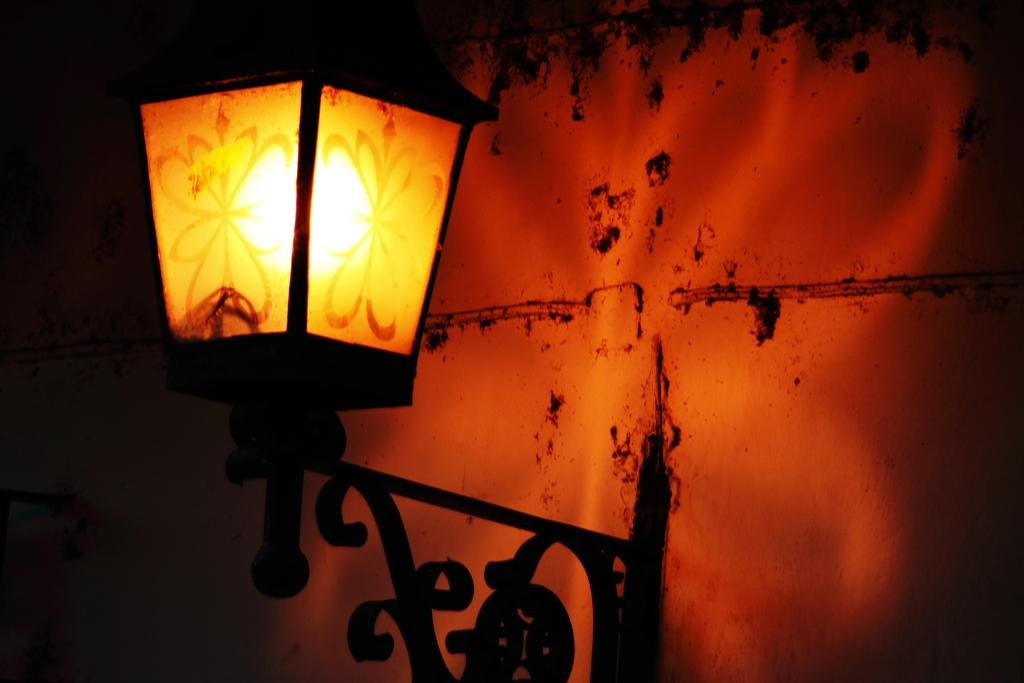What color is the lamp in the image? The lamp in the image is black. What can be seen behind the lamp in the image? There is a wall in the image. What type of light is visible in the image? There is yellow light and red light in the image. Where is the sister sitting near the seashore in the image? There is no sister or seashore present in the image; it only features a black color lamp and a wall. 